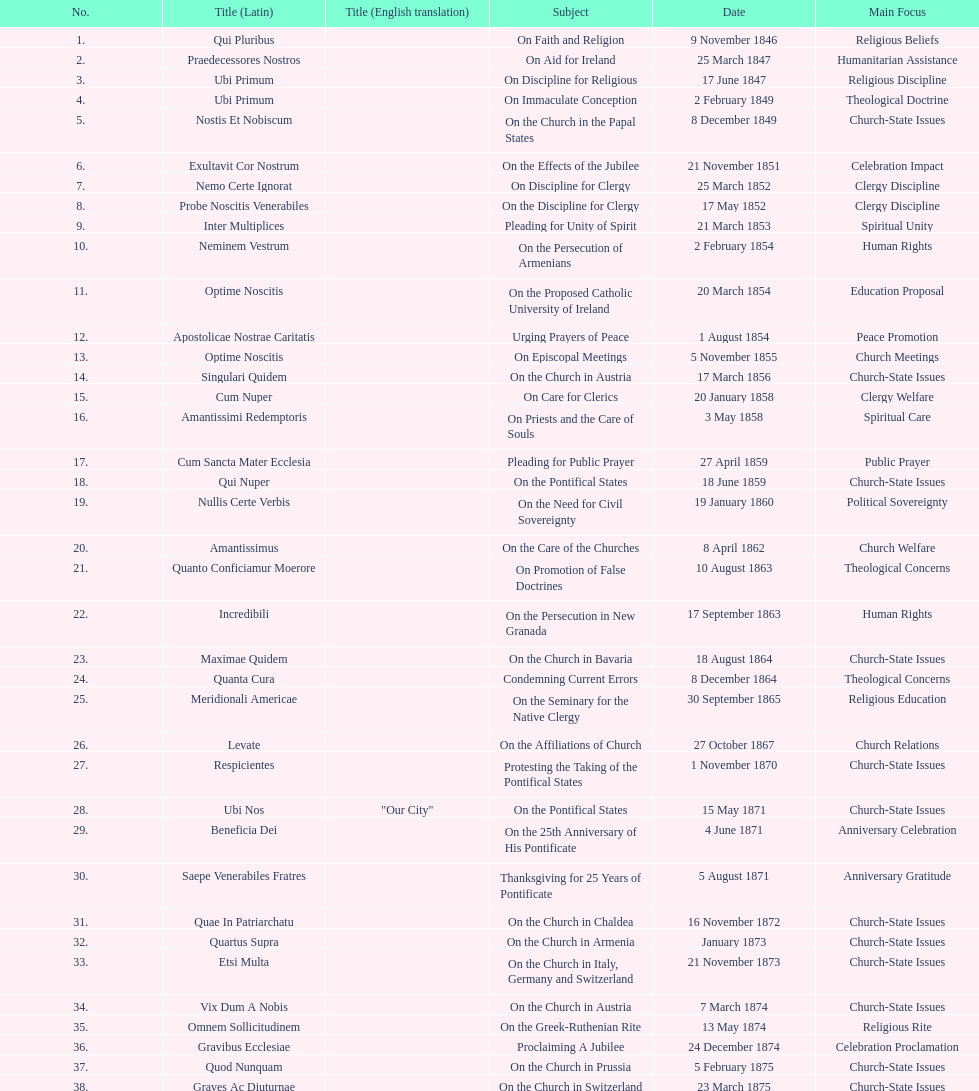Latin title of the encyclical before the encyclical with the subject "on the church in bavaria" Incredibili. I'm looking to parse the entire table for insights. Could you assist me with that? {'header': ['No.', 'Title (Latin)', 'Title (English translation)', 'Subject', 'Date', 'Main Focus'], 'rows': [['1.', 'Qui Pluribus', '', 'On Faith and Religion', '9 November 1846', 'Religious Beliefs'], ['2.', 'Praedecessores Nostros', '', 'On Aid for Ireland', '25 March 1847', 'Humanitarian Assistance'], ['3.', 'Ubi Primum', '', 'On Discipline for Religious', '17 June 1847', 'Religious Discipline'], ['4.', 'Ubi Primum', '', 'On Immaculate Conception', '2 February 1849', 'Theological Doctrine'], ['5.', 'Nostis Et Nobiscum', '', 'On the Church in the Papal States', '8 December 1849', 'Church-State Issues'], ['6.', 'Exultavit Cor Nostrum', '', 'On the Effects of the Jubilee', '21 November 1851', 'Celebration Impact'], ['7.', 'Nemo Certe Ignorat', '', 'On Discipline for Clergy', '25 March 1852', 'Clergy Discipline'], ['8.', 'Probe Noscitis Venerabiles', '', 'On the Discipline for Clergy', '17 May 1852', 'Clergy Discipline'], ['9.', 'Inter Multiplices', '', 'Pleading for Unity of Spirit', '21 March 1853', 'Spiritual Unity'], ['10.', 'Neminem Vestrum', '', 'On the Persecution of Armenians', '2 February 1854', 'Human Rights'], ['11.', 'Optime Noscitis', '', 'On the Proposed Catholic University of Ireland', '20 March 1854', 'Education Proposal'], ['12.', 'Apostolicae Nostrae Caritatis', '', 'Urging Prayers of Peace', '1 August 1854', 'Peace Promotion'], ['13.', 'Optime Noscitis', '', 'On Episcopal Meetings', '5 November 1855', 'Church Meetings'], ['14.', 'Singulari Quidem', '', 'On the Church in Austria', '17 March 1856', 'Church-State Issues'], ['15.', 'Cum Nuper', '', 'On Care for Clerics', '20 January 1858', 'Clergy Welfare'], ['16.', 'Amantissimi Redemptoris', '', 'On Priests and the Care of Souls', '3 May 1858', 'Spiritual Care'], ['17.', 'Cum Sancta Mater Ecclesia', '', 'Pleading for Public Prayer', '27 April 1859', 'Public Prayer'], ['18.', 'Qui Nuper', '', 'On the Pontifical States', '18 June 1859', 'Church-State Issues'], ['19.', 'Nullis Certe Verbis', '', 'On the Need for Civil Sovereignty', '19 January 1860', 'Political Sovereignty'], ['20.', 'Amantissimus', '', 'On the Care of the Churches', '8 April 1862', 'Church Welfare'], ['21.', 'Quanto Conficiamur Moerore', '', 'On Promotion of False Doctrines', '10 August 1863', 'Theological Concerns'], ['22.', 'Incredibili', '', 'On the Persecution in New Granada', '17 September 1863', 'Human Rights'], ['23.', 'Maximae Quidem', '', 'On the Church in Bavaria', '18 August 1864', 'Church-State Issues'], ['24.', 'Quanta Cura', '', 'Condemning Current Errors', '8 December 1864', 'Theological Concerns'], ['25.', 'Meridionali Americae', '', 'On the Seminary for the Native Clergy', '30 September 1865', 'Religious Education'], ['26.', 'Levate', '', 'On the Affiliations of Church', '27 October 1867', 'Church Relations'], ['27.', 'Respicientes', '', 'Protesting the Taking of the Pontifical States', '1 November 1870', 'Church-State Issues'], ['28.', 'Ubi Nos', '"Our City"', 'On the Pontifical States', '15 May 1871', 'Church-State Issues'], ['29.', 'Beneficia Dei', '', 'On the 25th Anniversary of His Pontificate', '4 June 1871', 'Anniversary Celebration'], ['30.', 'Saepe Venerabiles Fratres', '', 'Thanksgiving for 25 Years of Pontificate', '5 August 1871', 'Anniversary Gratitude'], ['31.', 'Quae In Patriarchatu', '', 'On the Church in Chaldea', '16 November 1872', 'Church-State Issues'], ['32.', 'Quartus Supra', '', 'On the Church in Armenia', 'January 1873', 'Church-State Issues'], ['33.', 'Etsi Multa', '', 'On the Church in Italy, Germany and Switzerland', '21 November 1873', 'Church-State Issues'], ['34.', 'Vix Dum A Nobis', '', 'On the Church in Austria', '7 March 1874', 'Church-State Issues'], ['35.', 'Omnem Sollicitudinem', '', 'On the Greek-Ruthenian Rite', '13 May 1874', 'Religious Rite'], ['36.', 'Gravibus Ecclesiae', '', 'Proclaiming A Jubilee', '24 December 1874', 'Celebration Proclamation'], ['37.', 'Quod Nunquam', '', 'On the Church in Prussia', '5 February 1875', 'Church-State Issues'], ['38.', 'Graves Ac Diuturnae', '', 'On the Church in Switzerland', '23 March 1875', 'Church-State Issues']]} 